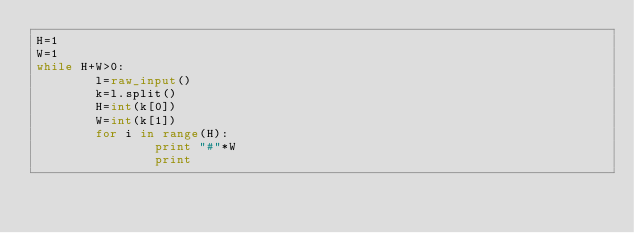<code> <loc_0><loc_0><loc_500><loc_500><_Python_>H=1
W=1
while H+W>0:
        l=raw_input()
        k=l.split()
        H=int(k[0])
        W=int(k[1])
        for i in range(H):
                print "#"*W
                print </code> 